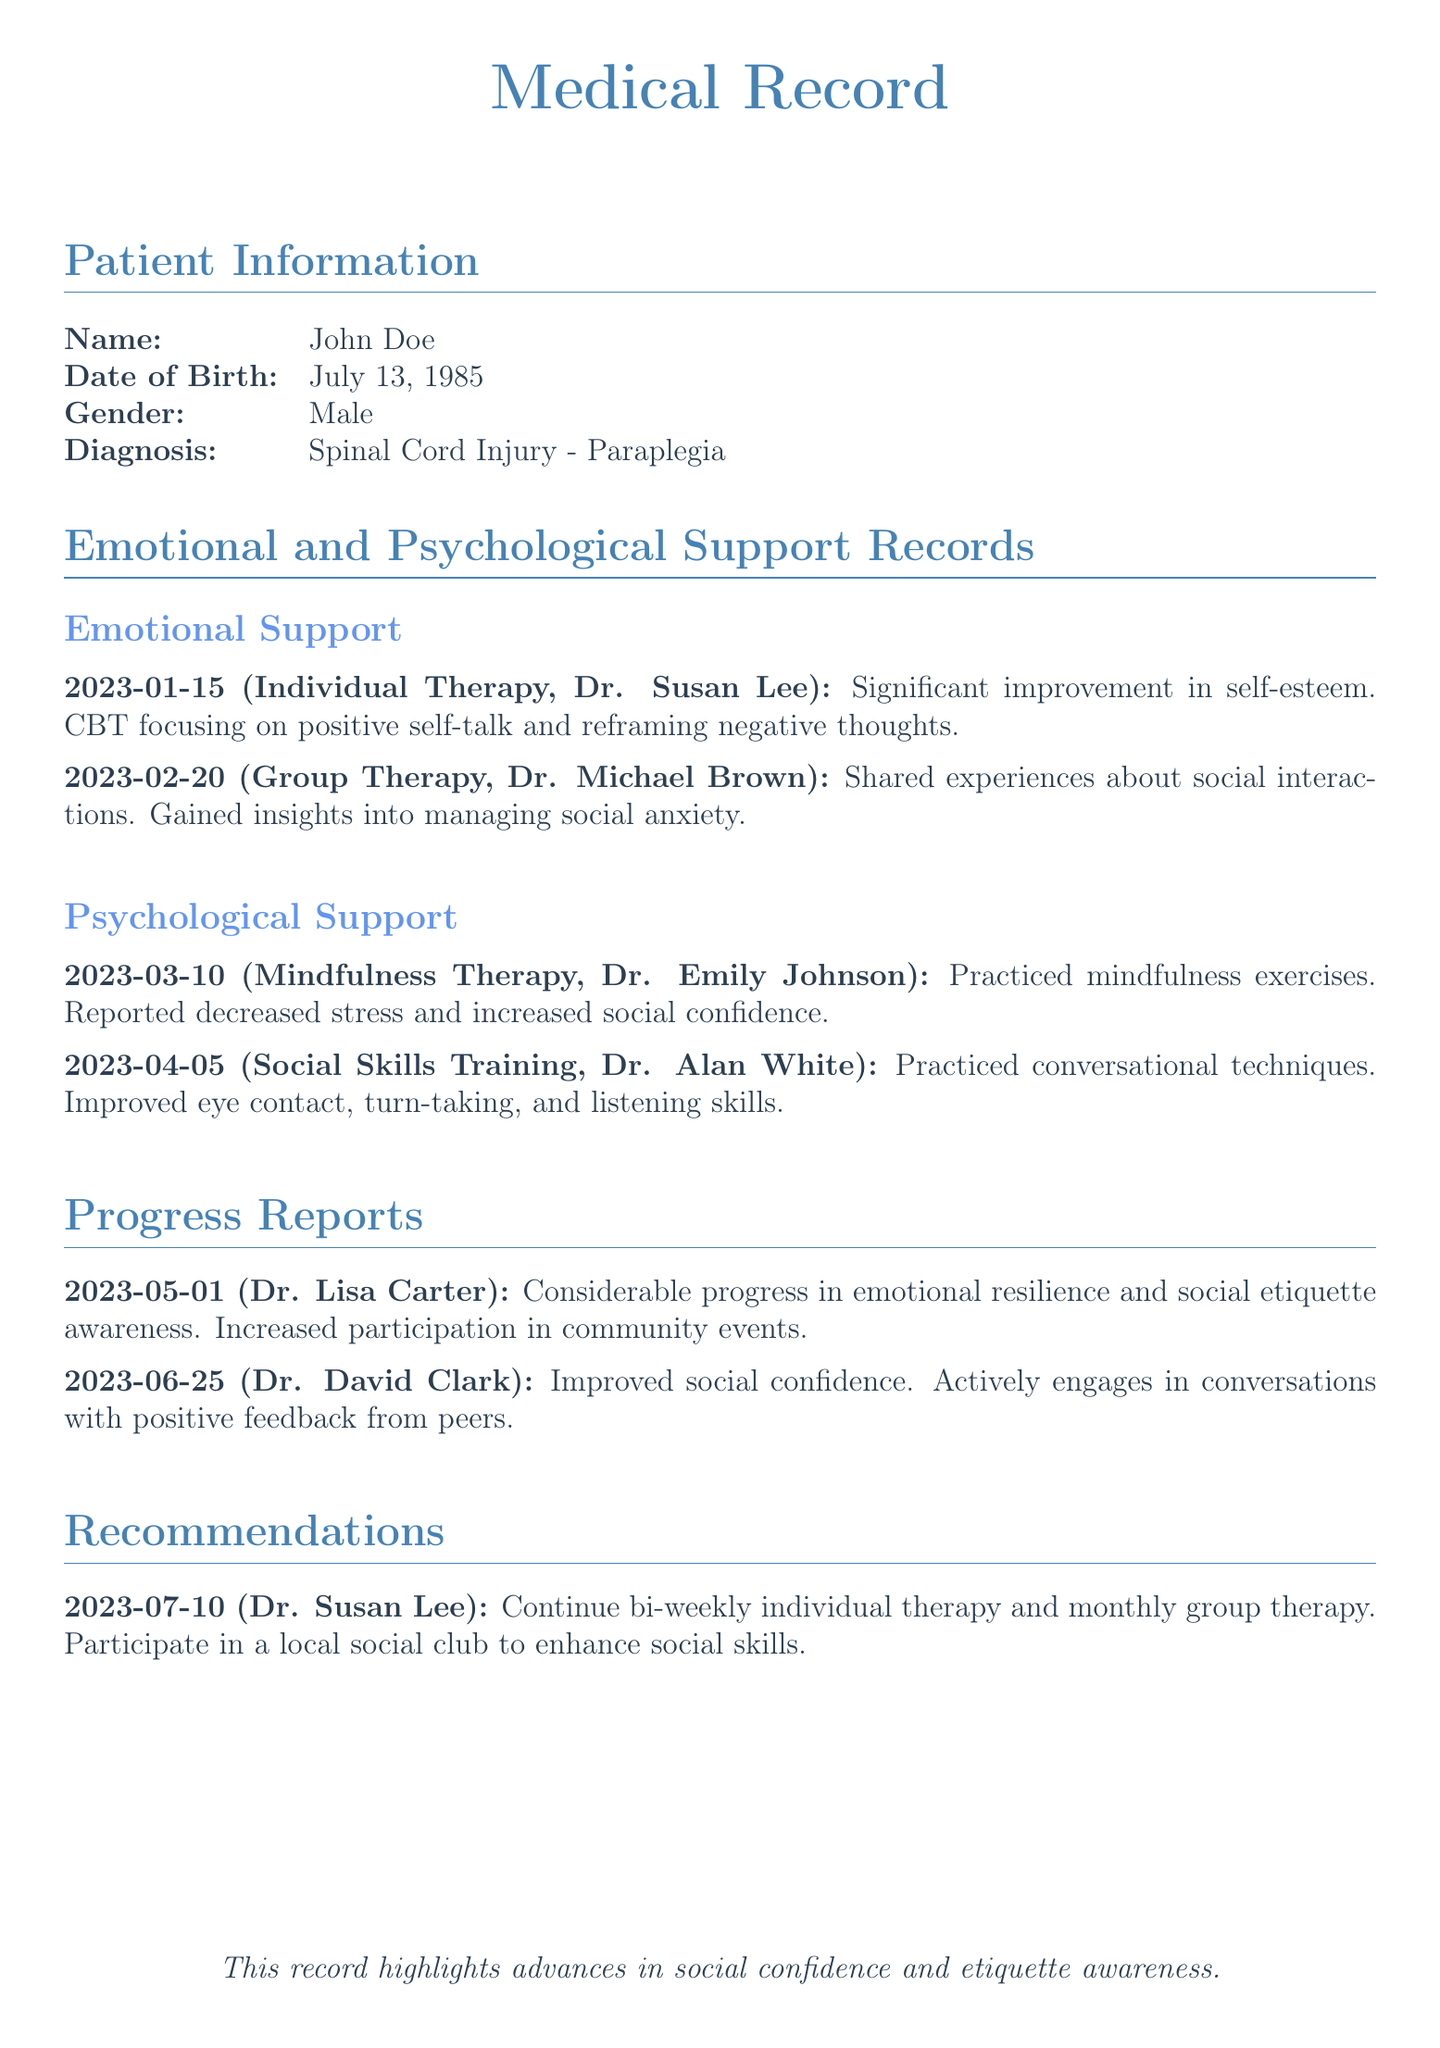What is the patient's name? The patient's name is listed in the patient information section as John Doe.
Answer: John Doe What is the diagnosis of the patient? The diagnosis is mentioned in the patient information section as Spinal Cord Injury - Paraplegia.
Answer: Spinal Cord Injury - Paraplegia When did the patient participate in individual therapy? The date of the individual therapy session is provided in the emotional support records as January 15, 2023.
Answer: January 15, 2023 Who provided mindfulness therapy to the patient? The mindfulness therapy session is attributed to Dr. Emily Johnson in the psychological support section.
Answer: Dr. Emily Johnson What was reported during the social skills training on April 5, 2023? The report from the social skills training session indicates improvement in conversational techniques, eye contact, turn-taking, and listening skills.
Answer: Improved eye contact, turn-taking, and listening skills How often does the patient attend individual therapy? The recommendation section suggests that the patient should continue bi-weekly individual therapy sessions.
Answer: Bi-weekly What was the main focus of the group therapy on February 20, 2023? The group therapy focused on shared experiences regarding social interactions and managing social anxiety.
Answer: Managing social anxiety What kind of progress was noted in the report from June 25, 2023? The progress report indicates improved social confidence, with the patient actively engaging in conversations.
Answer: Improved social confidence What recommendation was made for enhancing social skills? The document recommends participation in a local social club to enhance social skills.
Answer: Participate in a local social club 